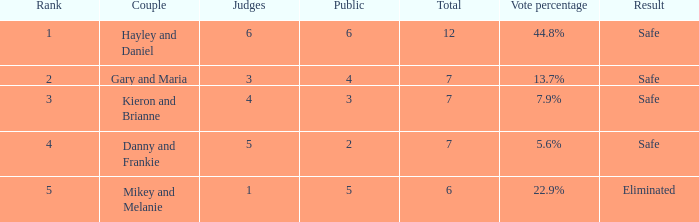What was the peak ranking for the vote percentage of 4.0. 